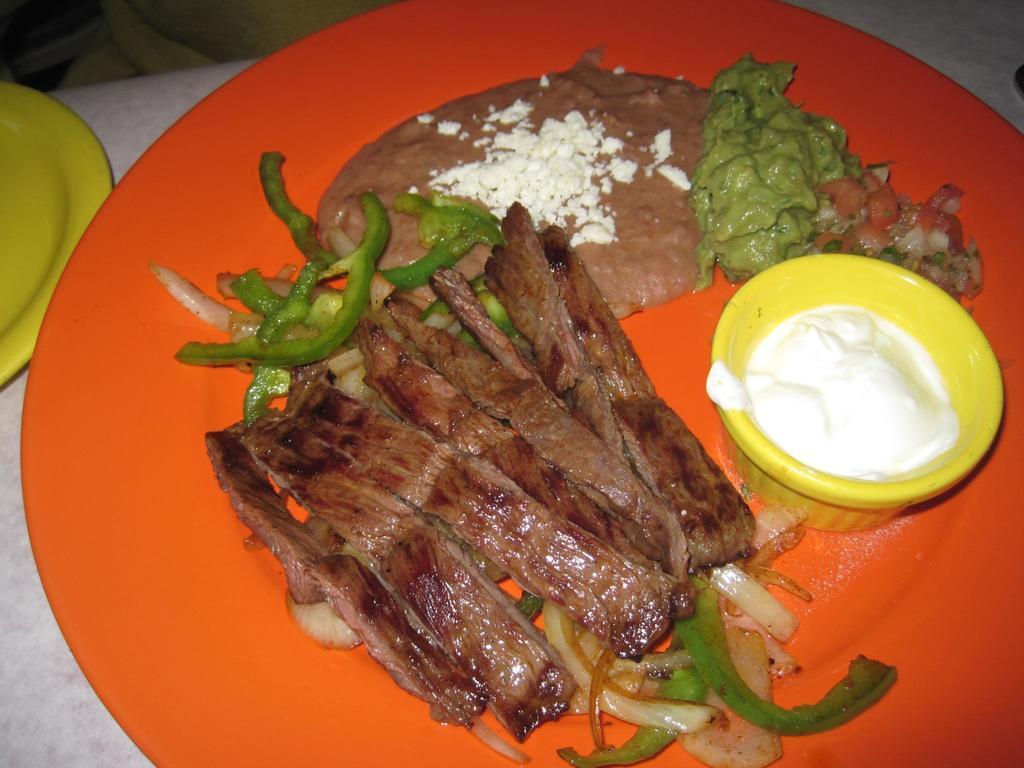Could you give a brief overview of what you see in this image? In the foreground of this image, there is some food and a cream in a bowl are placed on an orange platter which is on the stone surface. On the left, there is another platter. 